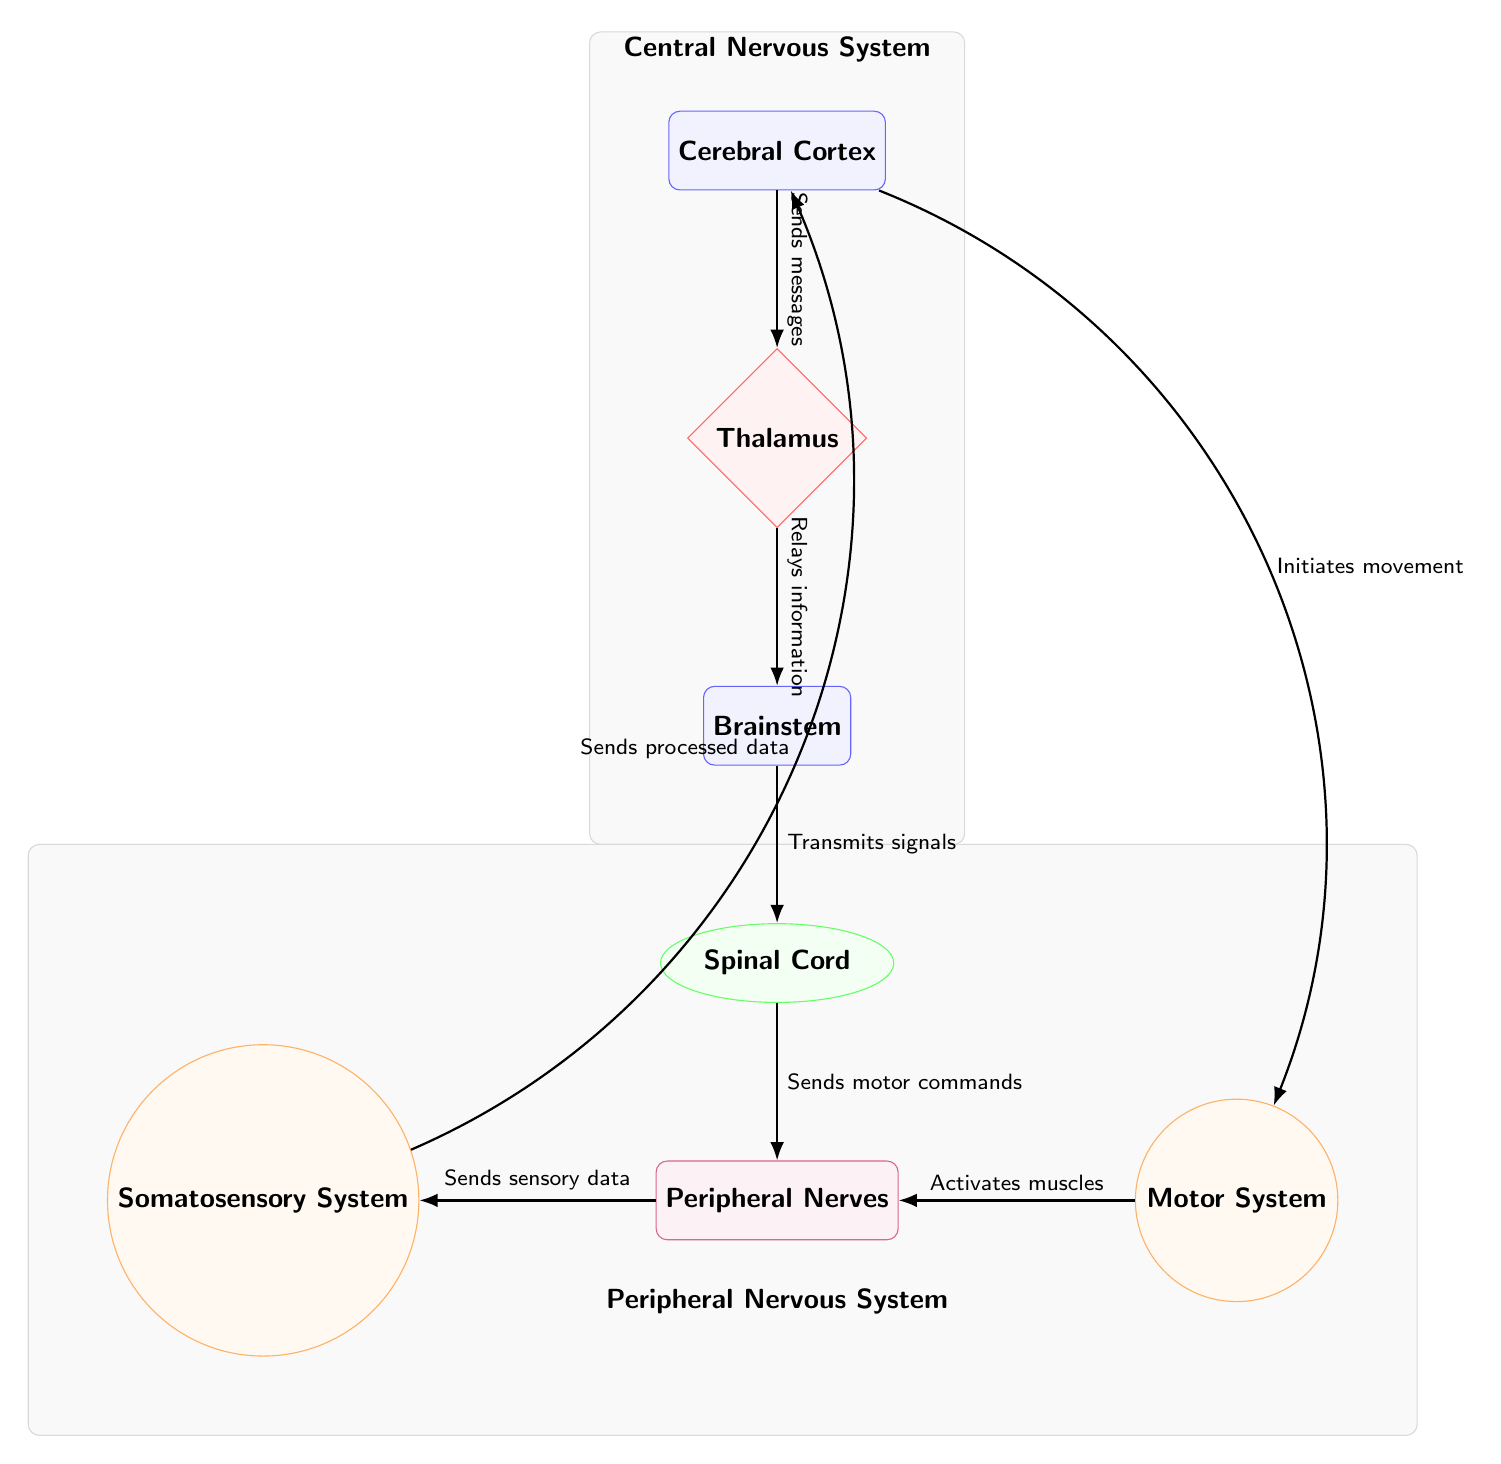What is the top node in the diagram? The top node in the diagram is the "Cerebral Cortex". This can be identified by the position of the nodes in the diagram where it is the highest node.
Answer: Cerebral Cortex How many main structures are present in the diagram? The main structures in the diagram are "Cerebral Cortex", "Thalamus", "Brainstem", and "Spinal Cord". Counting these nodes gives a total of four main structures.
Answer: 4 What type of relationship does the Thalamus have with the Brainstem? The relationship between the Thalamus and Brainstem is described by the edge labeled "Relays information", indicating that the Thalamus serves as a relay station for information.
Answer: Relays information Which system is on the left side of the Peripheral Nerves? The system on the left side of the Peripheral Nerves is labeled as the "Somatosensory System". This can be affirmed by the visual placement of the nodes.
Answer: Somatosensory System What does the Peripheral Nerves node send to the Somatosensory System? The Peripheral Nerves send "Sensory data" to the Somatosensory System as indicated by the labeled edge connecting these two nodes.
Answer: Sensory data What happens after the "Cerebral Cortex" initiates movement? After the "Cerebral Cortex" initiates movement, it activates the "Motor System". This is indicated by the labeled edge that connects these two nodes in a sequential flow of information.
Answer: Activates Motor System What are the two sub-systems connected to the Peripheral Nerves? The two sub-systems connected to the Peripheral Nerves are the "Somatosensory System" and the "Motor System", as identified by their respective positions next to the Peripheral Nerves.
Answer: Somatosensory System and Motor System What is the role of the Brainstem? The Brainstem's role is characterized by the labeled edge "Transmits signals", indicating that it serves as a conduit for signals within the nervous system.
Answer: Transmits signals How does the Somatosensory System communicate with the Cerebral Cortex? The communication is established through the edge labeled "Sends processed data". This demonstrates that the Somatosensory System sends information back to the Cerebral Cortex.
Answer: Sends processed data 